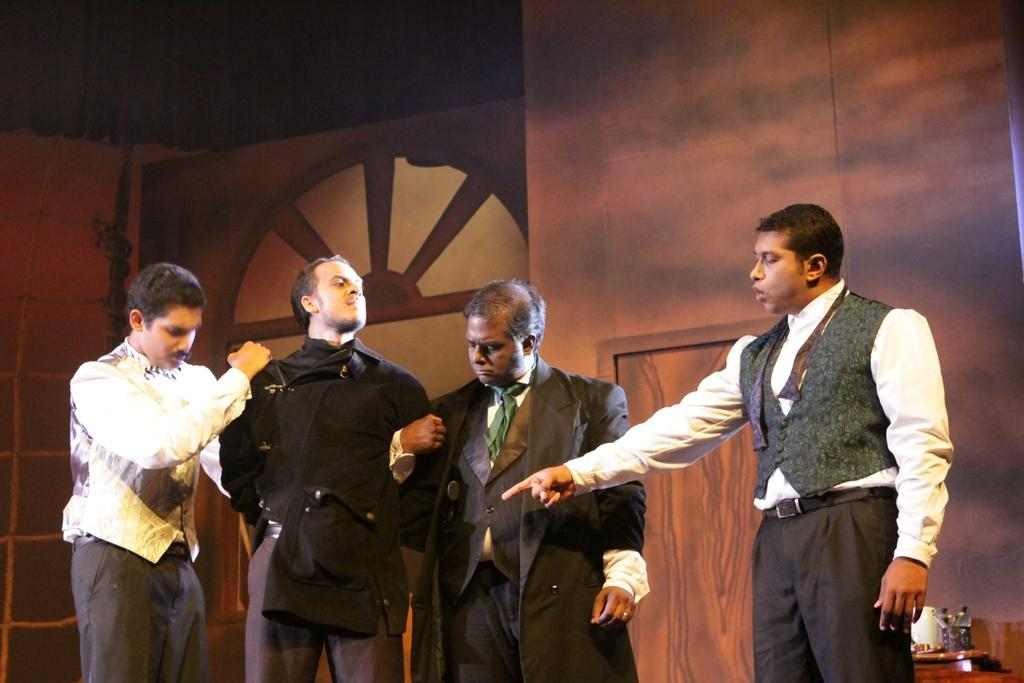What can be found in the right corner of the image? There are objects in the right corner of the image. Can you describe the people in the image? There are people standing in the image. What is located in the foreground of the image? There appears to be a door in the foreground of the image. What type of object can be seen in the background of the image? There is a wooden object in the background of the image. What type of paste is being used by the people in the image? There is no paste visible in the image, and the people are not using any paste. How many cows are present in the image? There are no cows present in the image. 